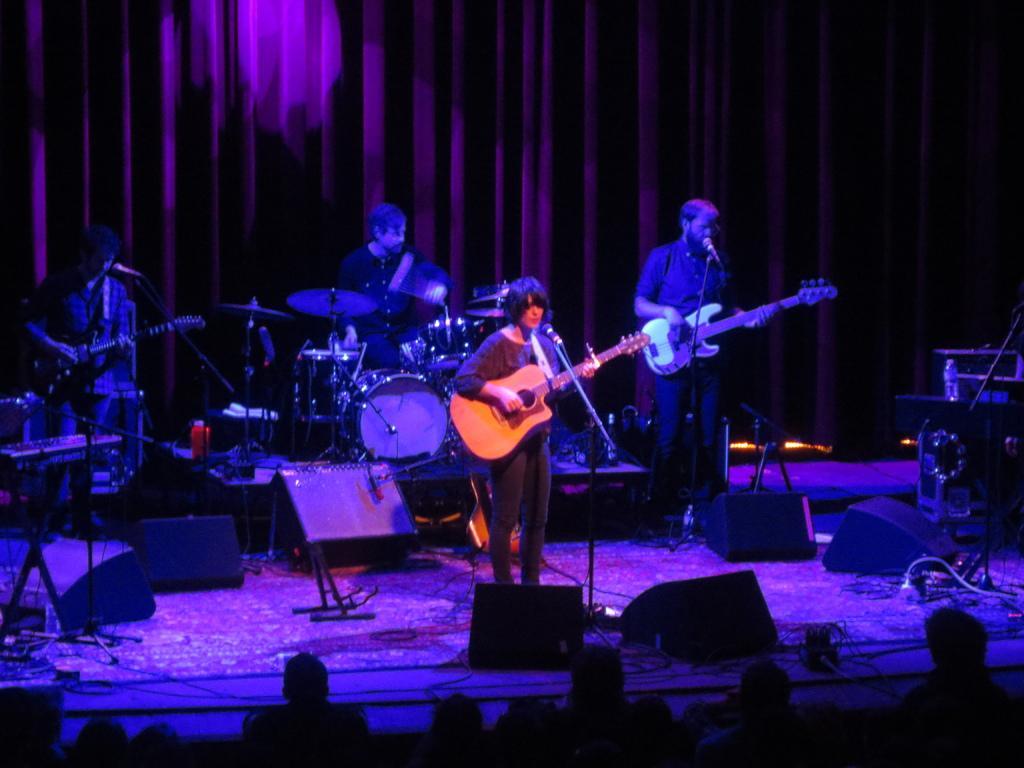Please provide a concise description of this image. Persons are playing musical instruments,here there is speaker and here there is crowd. 